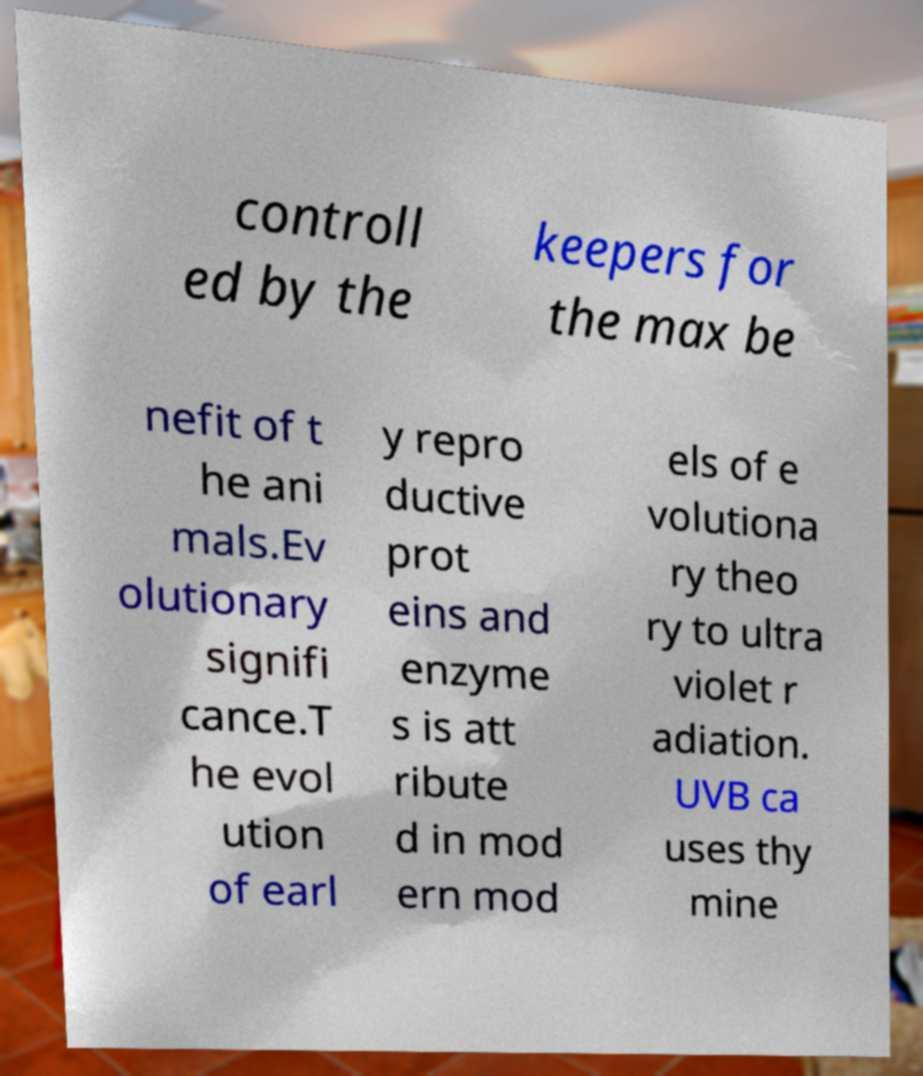I need the written content from this picture converted into text. Can you do that? controll ed by the keepers for the max be nefit of t he ani mals.Ev olutionary signifi cance.T he evol ution of earl y repro ductive prot eins and enzyme s is att ribute d in mod ern mod els of e volutiona ry theo ry to ultra violet r adiation. UVB ca uses thy mine 